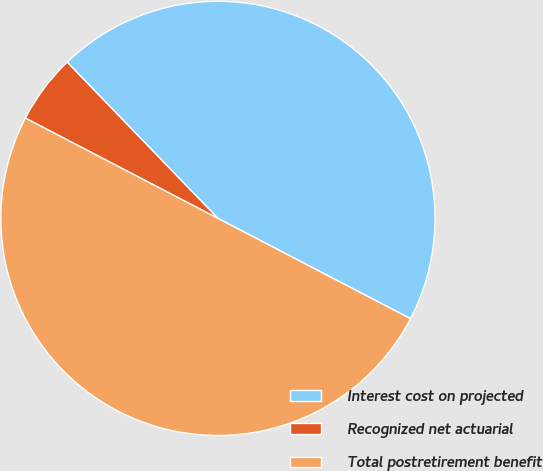Convert chart. <chart><loc_0><loc_0><loc_500><loc_500><pie_chart><fcel>Interest cost on projected<fcel>Recognized net actuarial<fcel>Total postretirement benefit<nl><fcel>44.86%<fcel>5.14%<fcel>50.0%<nl></chart> 